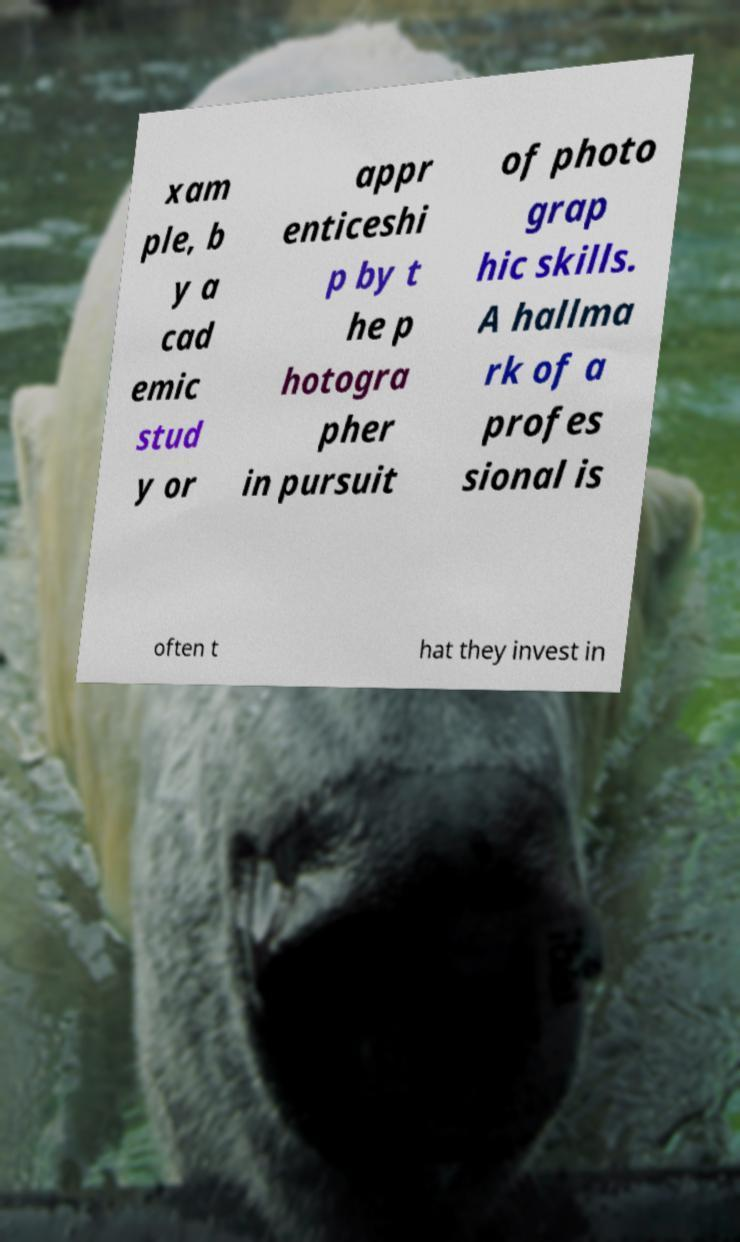Please read and relay the text visible in this image. What does it say? xam ple, b y a cad emic stud y or appr enticeshi p by t he p hotogra pher in pursuit of photo grap hic skills. A hallma rk of a profes sional is often t hat they invest in 